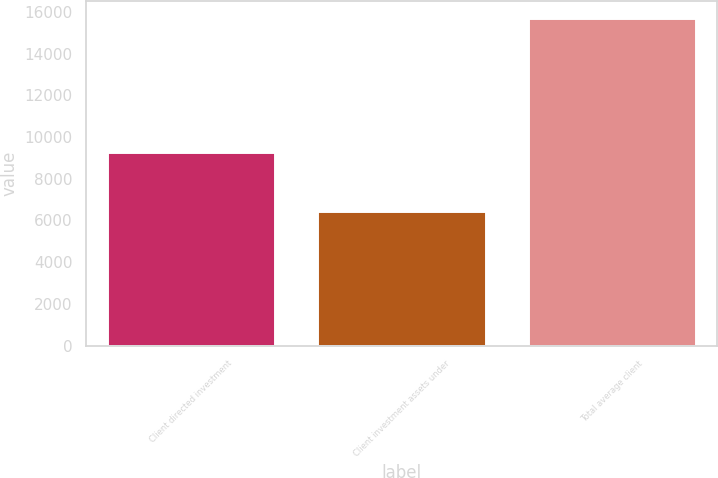Convert chart to OTSL. <chart><loc_0><loc_0><loc_500><loc_500><bar_chart><fcel>Client directed investment<fcel>Client investment assets under<fcel>Total average client<nl><fcel>9279<fcel>6432<fcel>15711<nl></chart> 